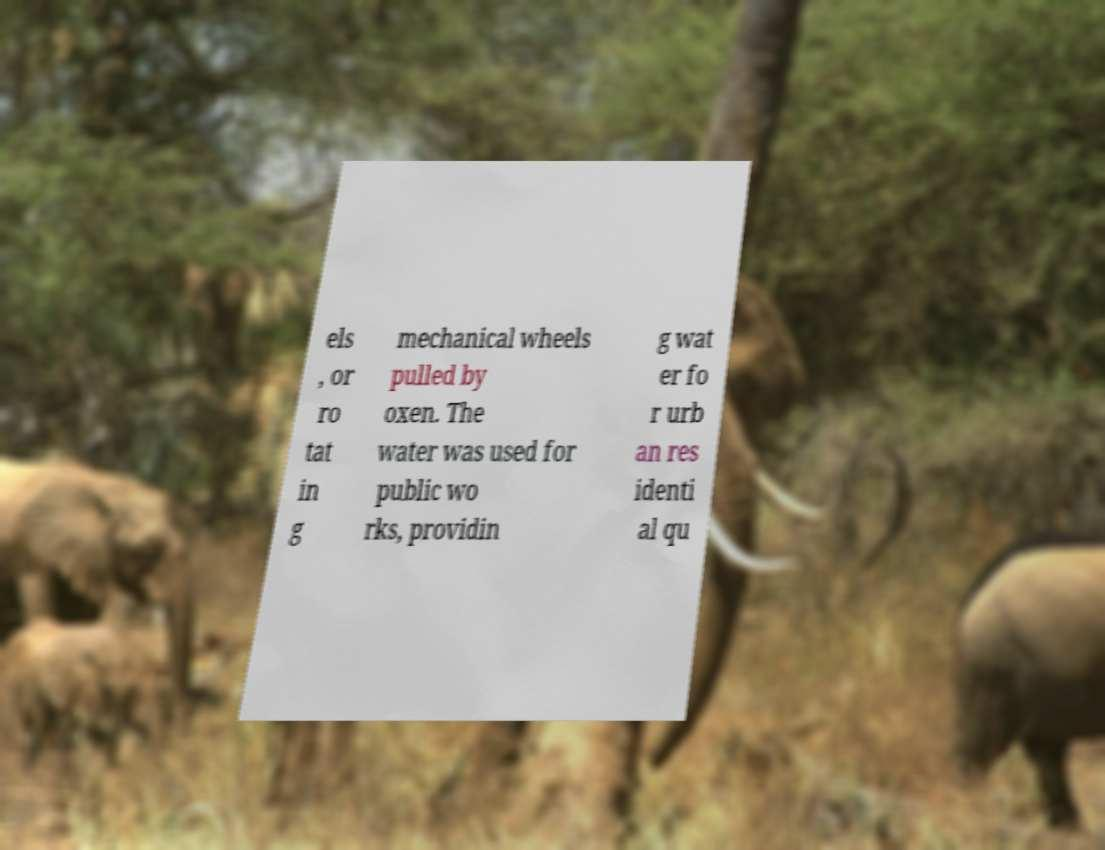I need the written content from this picture converted into text. Can you do that? els , or ro tat in g mechanical wheels pulled by oxen. The water was used for public wo rks, providin g wat er fo r urb an res identi al qu 